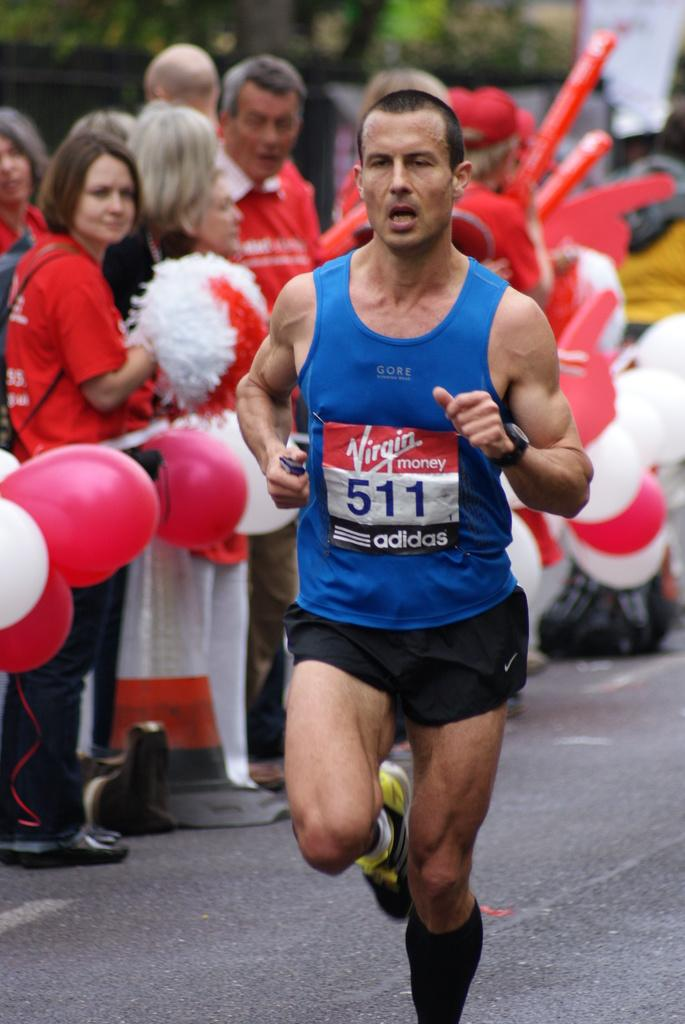Provide a one-sentence caption for the provided image. runner number 511 wearing blue and black going past crowd wearing red. 